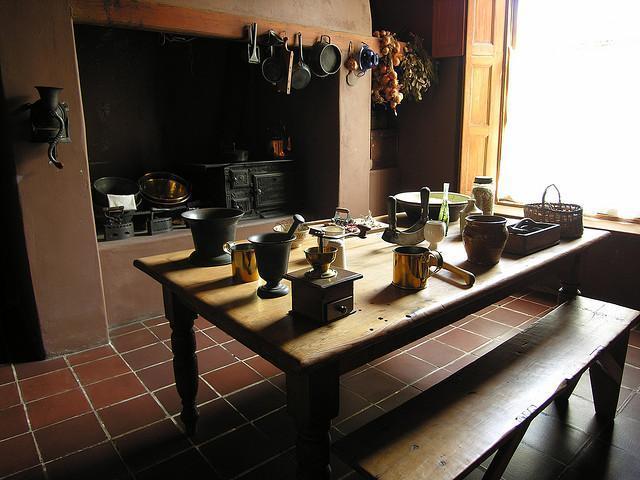How many benches are in the picture?
Give a very brief answer. 1. 